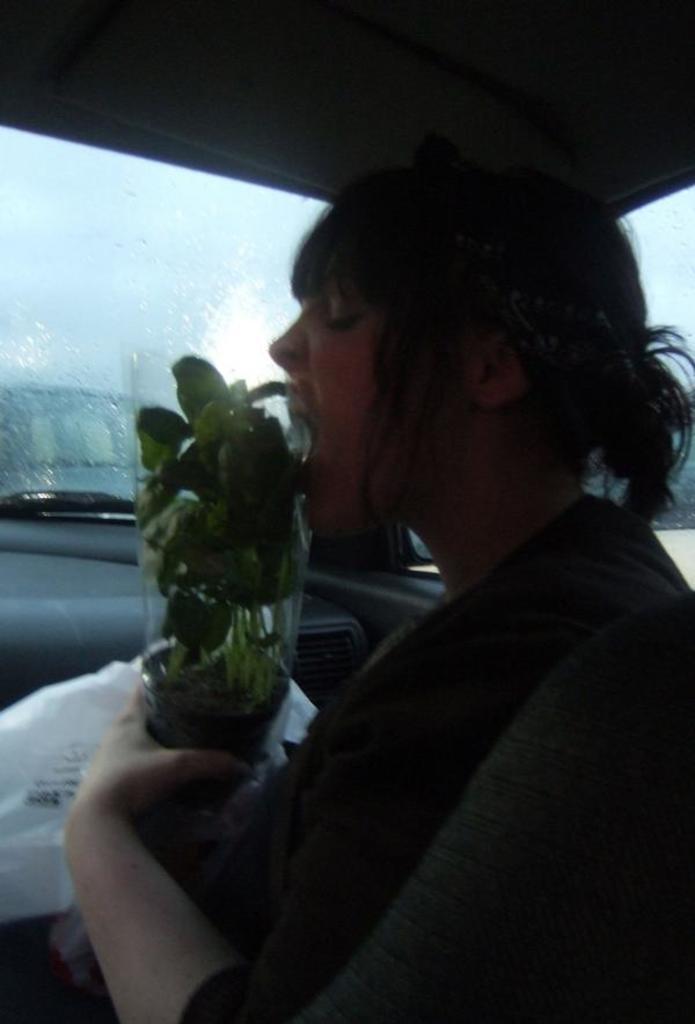How would you summarize this image in a sentence or two? In this picture we can see a woman holding a plant with her hand and a plastic cover inside a vehicle. In the background we can see the sky. 